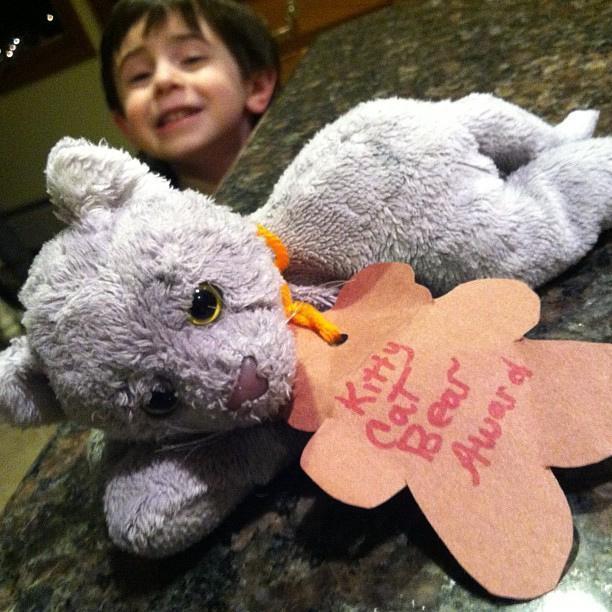Is "The teddy bear is on top of the dining table." an appropriate description for the image?
Answer yes or no. Yes. Is this affirmation: "The person is against the teddy bear." correct?
Answer yes or no. No. Does the image validate the caption "The dining table is touching the teddy bear."?
Answer yes or no. Yes. 